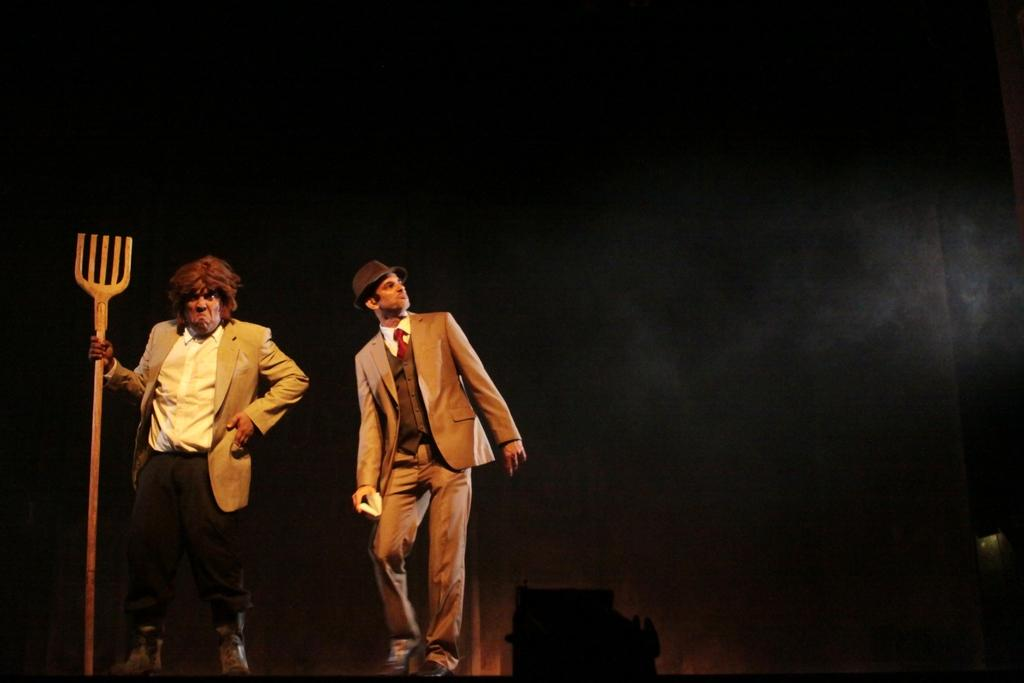What type of scene might the image depict? The image may be from a drama. How are the two persons in the image dressed? They are both wearing suits. What object is one person holding in the image? One person is holding a trident. What can be observed about the lighting in the image? The background of the image is dark. What type of test can be seen being conducted in the image? There is no test being conducted in the image; it features two persons wearing suits and one holding a trident. What type of lace is used to decorate the suits in the image? There is no lace visible on the suits in the image; they are simply described as suits. 